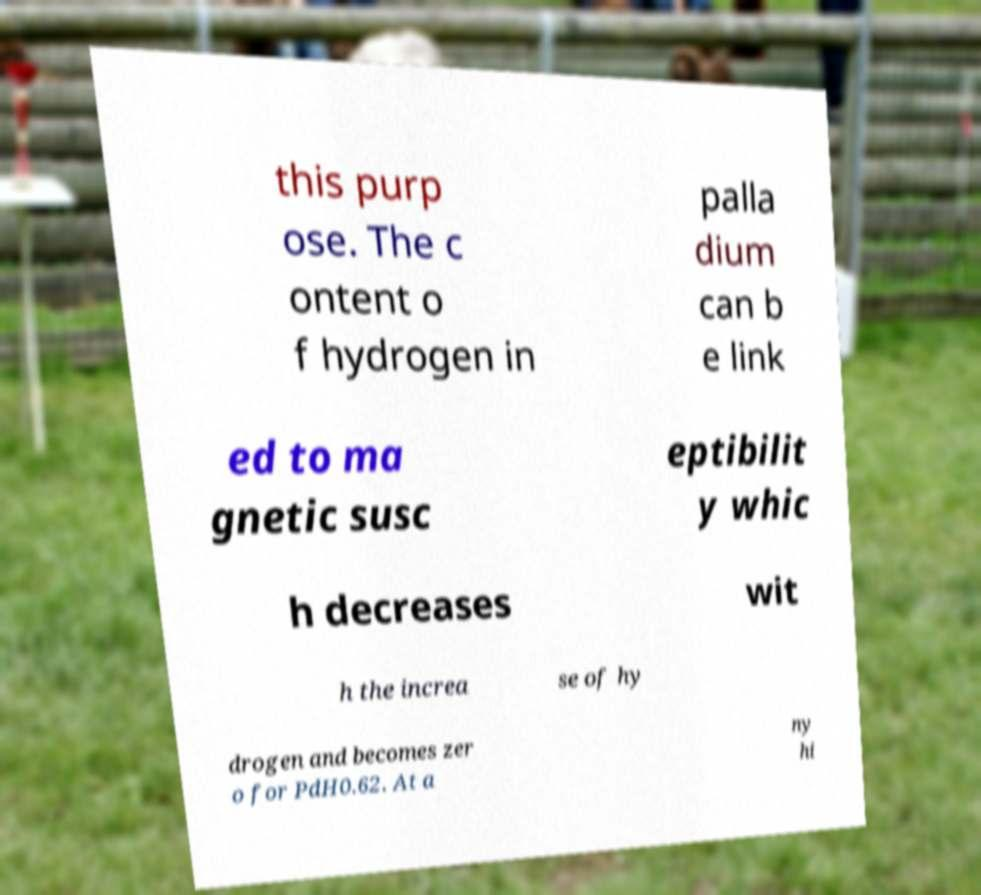What messages or text are displayed in this image? I need them in a readable, typed format. this purp ose. The c ontent o f hydrogen in palla dium can b e link ed to ma gnetic susc eptibilit y whic h decreases wit h the increa se of hy drogen and becomes zer o for PdH0.62. At a ny hi 